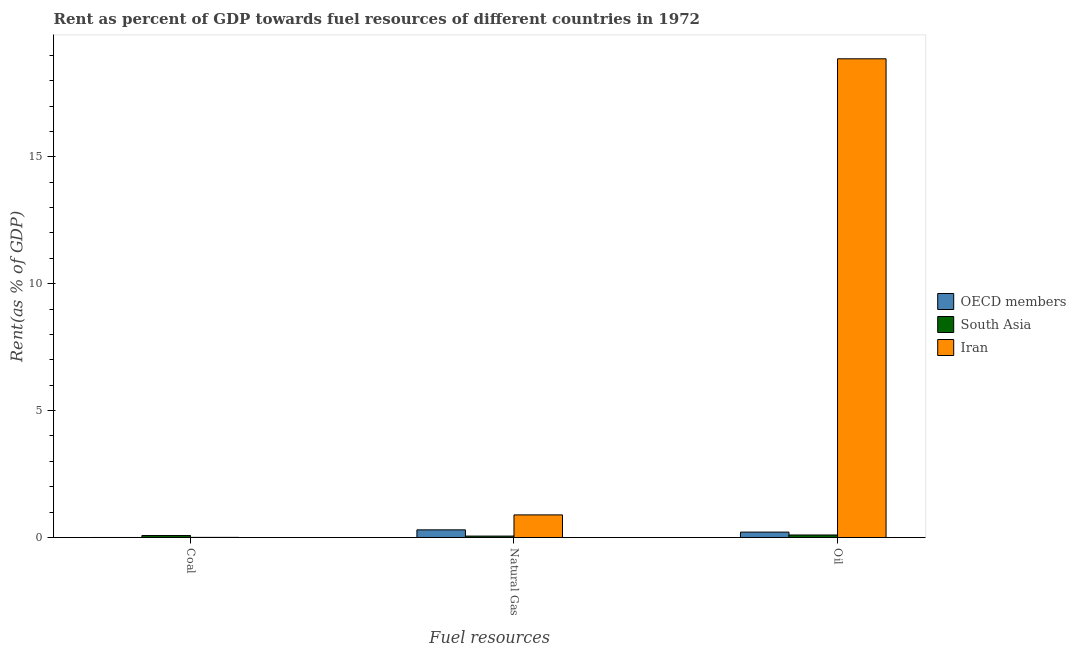Are the number of bars per tick equal to the number of legend labels?
Your answer should be compact. Yes. Are the number of bars on each tick of the X-axis equal?
Keep it short and to the point. Yes. What is the label of the 2nd group of bars from the left?
Provide a short and direct response. Natural Gas. What is the rent towards coal in South Asia?
Ensure brevity in your answer.  0.08. Across all countries, what is the maximum rent towards natural gas?
Provide a succinct answer. 0.89. Across all countries, what is the minimum rent towards natural gas?
Your response must be concise. 0.06. In which country was the rent towards coal minimum?
Make the answer very short. OECD members. What is the total rent towards coal in the graph?
Provide a short and direct response. 0.08. What is the difference between the rent towards oil in South Asia and that in Iran?
Give a very brief answer. -18.76. What is the difference between the rent towards natural gas in OECD members and the rent towards oil in Iran?
Keep it short and to the point. -18.56. What is the average rent towards oil per country?
Offer a terse response. 6.39. What is the difference between the rent towards coal and rent towards natural gas in Iran?
Keep it short and to the point. -0.89. In how many countries, is the rent towards oil greater than 17 %?
Provide a short and direct response. 1. What is the ratio of the rent towards natural gas in OECD members to that in Iran?
Keep it short and to the point. 0.34. Is the rent towards oil in OECD members less than that in Iran?
Ensure brevity in your answer.  Yes. What is the difference between the highest and the second highest rent towards oil?
Your response must be concise. 18.65. What is the difference between the highest and the lowest rent towards natural gas?
Provide a short and direct response. 0.83. In how many countries, is the rent towards coal greater than the average rent towards coal taken over all countries?
Give a very brief answer. 1. Is the sum of the rent towards coal in South Asia and OECD members greater than the maximum rent towards oil across all countries?
Provide a succinct answer. No. Are all the bars in the graph horizontal?
Give a very brief answer. No. What is the difference between two consecutive major ticks on the Y-axis?
Your answer should be compact. 5. Are the values on the major ticks of Y-axis written in scientific E-notation?
Your answer should be compact. No. Does the graph contain any zero values?
Keep it short and to the point. No. Does the graph contain grids?
Your response must be concise. No. Where does the legend appear in the graph?
Provide a succinct answer. Center right. What is the title of the graph?
Your answer should be compact. Rent as percent of GDP towards fuel resources of different countries in 1972. What is the label or title of the X-axis?
Your answer should be very brief. Fuel resources. What is the label or title of the Y-axis?
Provide a succinct answer. Rent(as % of GDP). What is the Rent(as % of GDP) of OECD members in Coal?
Make the answer very short. 2.27630170157113e-6. What is the Rent(as % of GDP) in South Asia in Coal?
Provide a succinct answer. 0.08. What is the Rent(as % of GDP) in Iran in Coal?
Keep it short and to the point. 0. What is the Rent(as % of GDP) of OECD members in Natural Gas?
Your response must be concise. 0.3. What is the Rent(as % of GDP) of South Asia in Natural Gas?
Your answer should be very brief. 0.06. What is the Rent(as % of GDP) in Iran in Natural Gas?
Make the answer very short. 0.89. What is the Rent(as % of GDP) of OECD members in Oil?
Provide a short and direct response. 0.21. What is the Rent(as % of GDP) in South Asia in Oil?
Your answer should be compact. 0.1. What is the Rent(as % of GDP) in Iran in Oil?
Offer a very short reply. 18.86. Across all Fuel resources, what is the maximum Rent(as % of GDP) in OECD members?
Ensure brevity in your answer.  0.3. Across all Fuel resources, what is the maximum Rent(as % of GDP) of South Asia?
Provide a succinct answer. 0.1. Across all Fuel resources, what is the maximum Rent(as % of GDP) of Iran?
Provide a short and direct response. 18.86. Across all Fuel resources, what is the minimum Rent(as % of GDP) in OECD members?
Make the answer very short. 2.27630170157113e-6. Across all Fuel resources, what is the minimum Rent(as % of GDP) in South Asia?
Your response must be concise. 0.06. Across all Fuel resources, what is the minimum Rent(as % of GDP) in Iran?
Ensure brevity in your answer.  0. What is the total Rent(as % of GDP) in OECD members in the graph?
Your answer should be very brief. 0.51. What is the total Rent(as % of GDP) in South Asia in the graph?
Provide a short and direct response. 0.23. What is the total Rent(as % of GDP) of Iran in the graph?
Your answer should be very brief. 19.76. What is the difference between the Rent(as % of GDP) in OECD members in Coal and that in Natural Gas?
Your answer should be very brief. -0.3. What is the difference between the Rent(as % of GDP) in South Asia in Coal and that in Natural Gas?
Give a very brief answer. 0.02. What is the difference between the Rent(as % of GDP) of Iran in Coal and that in Natural Gas?
Offer a terse response. -0.89. What is the difference between the Rent(as % of GDP) of OECD members in Coal and that in Oil?
Provide a succinct answer. -0.21. What is the difference between the Rent(as % of GDP) of South Asia in Coal and that in Oil?
Offer a very short reply. -0.02. What is the difference between the Rent(as % of GDP) of Iran in Coal and that in Oil?
Your response must be concise. -18.86. What is the difference between the Rent(as % of GDP) of OECD members in Natural Gas and that in Oil?
Provide a short and direct response. 0.09. What is the difference between the Rent(as % of GDP) in South Asia in Natural Gas and that in Oil?
Keep it short and to the point. -0.04. What is the difference between the Rent(as % of GDP) in Iran in Natural Gas and that in Oil?
Ensure brevity in your answer.  -17.97. What is the difference between the Rent(as % of GDP) in OECD members in Coal and the Rent(as % of GDP) in South Asia in Natural Gas?
Ensure brevity in your answer.  -0.06. What is the difference between the Rent(as % of GDP) of OECD members in Coal and the Rent(as % of GDP) of Iran in Natural Gas?
Offer a terse response. -0.89. What is the difference between the Rent(as % of GDP) of South Asia in Coal and the Rent(as % of GDP) of Iran in Natural Gas?
Your response must be concise. -0.81. What is the difference between the Rent(as % of GDP) in OECD members in Coal and the Rent(as % of GDP) in South Asia in Oil?
Offer a terse response. -0.1. What is the difference between the Rent(as % of GDP) of OECD members in Coal and the Rent(as % of GDP) of Iran in Oil?
Offer a terse response. -18.86. What is the difference between the Rent(as % of GDP) in South Asia in Coal and the Rent(as % of GDP) in Iran in Oil?
Provide a short and direct response. -18.78. What is the difference between the Rent(as % of GDP) of OECD members in Natural Gas and the Rent(as % of GDP) of South Asia in Oil?
Make the answer very short. 0.2. What is the difference between the Rent(as % of GDP) of OECD members in Natural Gas and the Rent(as % of GDP) of Iran in Oil?
Provide a short and direct response. -18.56. What is the difference between the Rent(as % of GDP) of South Asia in Natural Gas and the Rent(as % of GDP) of Iran in Oil?
Offer a very short reply. -18.81. What is the average Rent(as % of GDP) of OECD members per Fuel resources?
Give a very brief answer. 0.17. What is the average Rent(as % of GDP) in South Asia per Fuel resources?
Provide a succinct answer. 0.08. What is the average Rent(as % of GDP) in Iran per Fuel resources?
Provide a succinct answer. 6.59. What is the difference between the Rent(as % of GDP) of OECD members and Rent(as % of GDP) of South Asia in Coal?
Give a very brief answer. -0.08. What is the difference between the Rent(as % of GDP) in OECD members and Rent(as % of GDP) in Iran in Coal?
Give a very brief answer. -0. What is the difference between the Rent(as % of GDP) in South Asia and Rent(as % of GDP) in Iran in Coal?
Make the answer very short. 0.07. What is the difference between the Rent(as % of GDP) in OECD members and Rent(as % of GDP) in South Asia in Natural Gas?
Ensure brevity in your answer.  0.25. What is the difference between the Rent(as % of GDP) of OECD members and Rent(as % of GDP) of Iran in Natural Gas?
Make the answer very short. -0.59. What is the difference between the Rent(as % of GDP) of South Asia and Rent(as % of GDP) of Iran in Natural Gas?
Offer a terse response. -0.83. What is the difference between the Rent(as % of GDP) of OECD members and Rent(as % of GDP) of South Asia in Oil?
Your response must be concise. 0.11. What is the difference between the Rent(as % of GDP) of OECD members and Rent(as % of GDP) of Iran in Oil?
Make the answer very short. -18.65. What is the difference between the Rent(as % of GDP) of South Asia and Rent(as % of GDP) of Iran in Oil?
Offer a terse response. -18.76. What is the ratio of the Rent(as % of GDP) of OECD members in Coal to that in Natural Gas?
Keep it short and to the point. 0. What is the ratio of the Rent(as % of GDP) in South Asia in Coal to that in Natural Gas?
Provide a succinct answer. 1.4. What is the ratio of the Rent(as % of GDP) of Iran in Coal to that in Natural Gas?
Your response must be concise. 0. What is the ratio of the Rent(as % of GDP) in OECD members in Coal to that in Oil?
Keep it short and to the point. 0. What is the ratio of the Rent(as % of GDP) of South Asia in Coal to that in Oil?
Your response must be concise. 0.78. What is the ratio of the Rent(as % of GDP) of Iran in Coal to that in Oil?
Ensure brevity in your answer.  0. What is the ratio of the Rent(as % of GDP) in OECD members in Natural Gas to that in Oil?
Keep it short and to the point. 1.42. What is the ratio of the Rent(as % of GDP) of South Asia in Natural Gas to that in Oil?
Keep it short and to the point. 0.56. What is the ratio of the Rent(as % of GDP) in Iran in Natural Gas to that in Oil?
Offer a very short reply. 0.05. What is the difference between the highest and the second highest Rent(as % of GDP) in OECD members?
Your answer should be very brief. 0.09. What is the difference between the highest and the second highest Rent(as % of GDP) in South Asia?
Ensure brevity in your answer.  0.02. What is the difference between the highest and the second highest Rent(as % of GDP) of Iran?
Offer a terse response. 17.97. What is the difference between the highest and the lowest Rent(as % of GDP) of OECD members?
Your answer should be compact. 0.3. What is the difference between the highest and the lowest Rent(as % of GDP) of South Asia?
Make the answer very short. 0.04. What is the difference between the highest and the lowest Rent(as % of GDP) in Iran?
Offer a terse response. 18.86. 